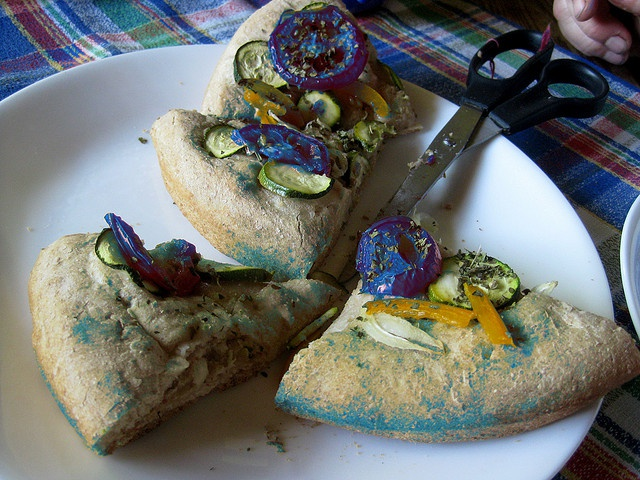Describe the objects in this image and their specific colors. I can see pizza in darkgreen, tan, darkgray, gray, and black tones, pizza in darkgreen, black, gray, and beige tones, pizza in darkgreen, black, lightgray, tan, and darkgray tones, pizza in darkgreen, black, olive, maroon, and lightgray tones, and scissors in darkgreen, black, gray, teal, and navy tones in this image. 